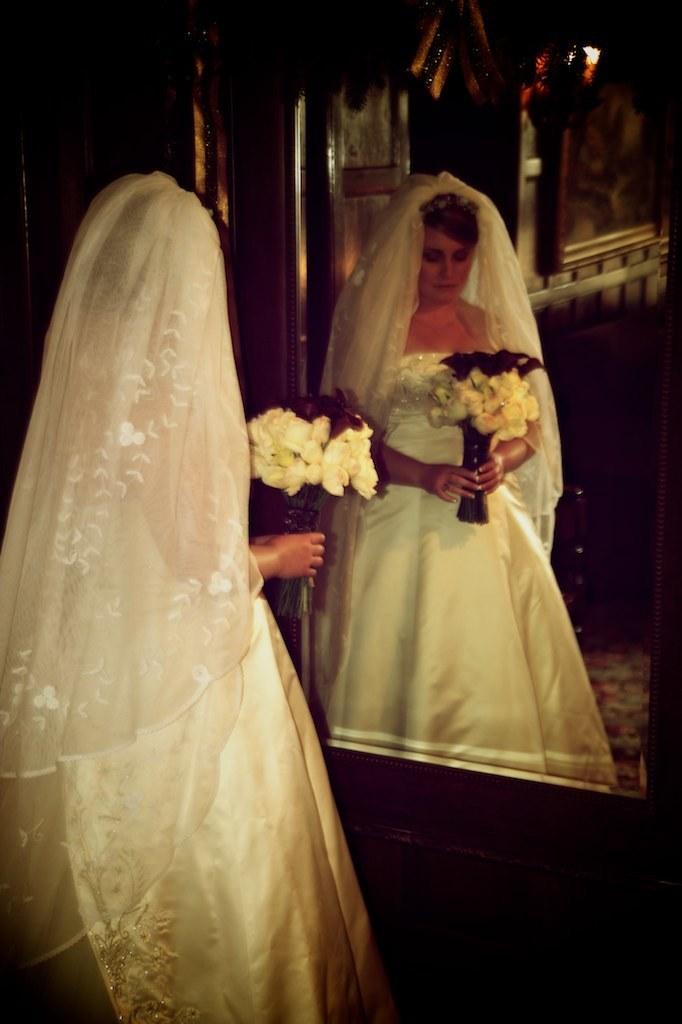Please provide a concise description of this image. In the image we can see a woman standing, wearing clothes and holding flower bookey in hands. In front of her there is a mirror, in the mirror we can see the reflection of the woman. The corners of the image are dark. 